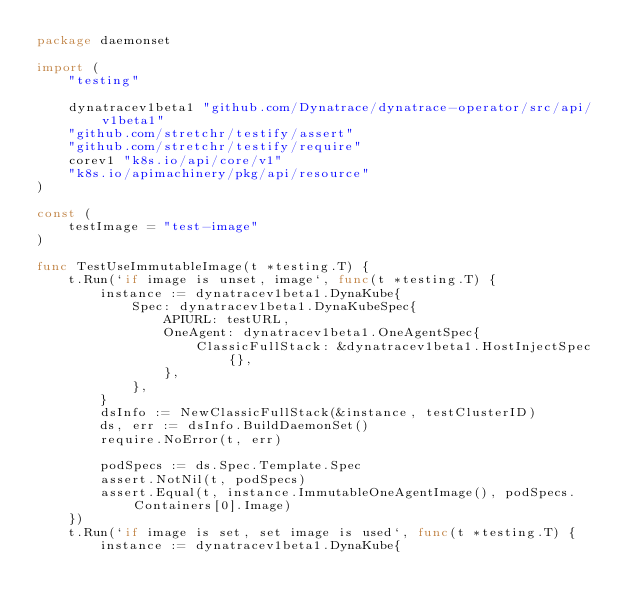<code> <loc_0><loc_0><loc_500><loc_500><_Go_>package daemonset

import (
	"testing"

	dynatracev1beta1 "github.com/Dynatrace/dynatrace-operator/src/api/v1beta1"
	"github.com/stretchr/testify/assert"
	"github.com/stretchr/testify/require"
	corev1 "k8s.io/api/core/v1"
	"k8s.io/apimachinery/pkg/api/resource"
)

const (
	testImage = "test-image"
)

func TestUseImmutableImage(t *testing.T) {
	t.Run(`if image is unset, image`, func(t *testing.T) {
		instance := dynatracev1beta1.DynaKube{
			Spec: dynatracev1beta1.DynaKubeSpec{
				APIURL: testURL,
				OneAgent: dynatracev1beta1.OneAgentSpec{
					ClassicFullStack: &dynatracev1beta1.HostInjectSpec{},
				},
			},
		}
		dsInfo := NewClassicFullStack(&instance, testClusterID)
		ds, err := dsInfo.BuildDaemonSet()
		require.NoError(t, err)

		podSpecs := ds.Spec.Template.Spec
		assert.NotNil(t, podSpecs)
		assert.Equal(t, instance.ImmutableOneAgentImage(), podSpecs.Containers[0].Image)
	})
	t.Run(`if image is set, set image is used`, func(t *testing.T) {
		instance := dynatracev1beta1.DynaKube{</code> 